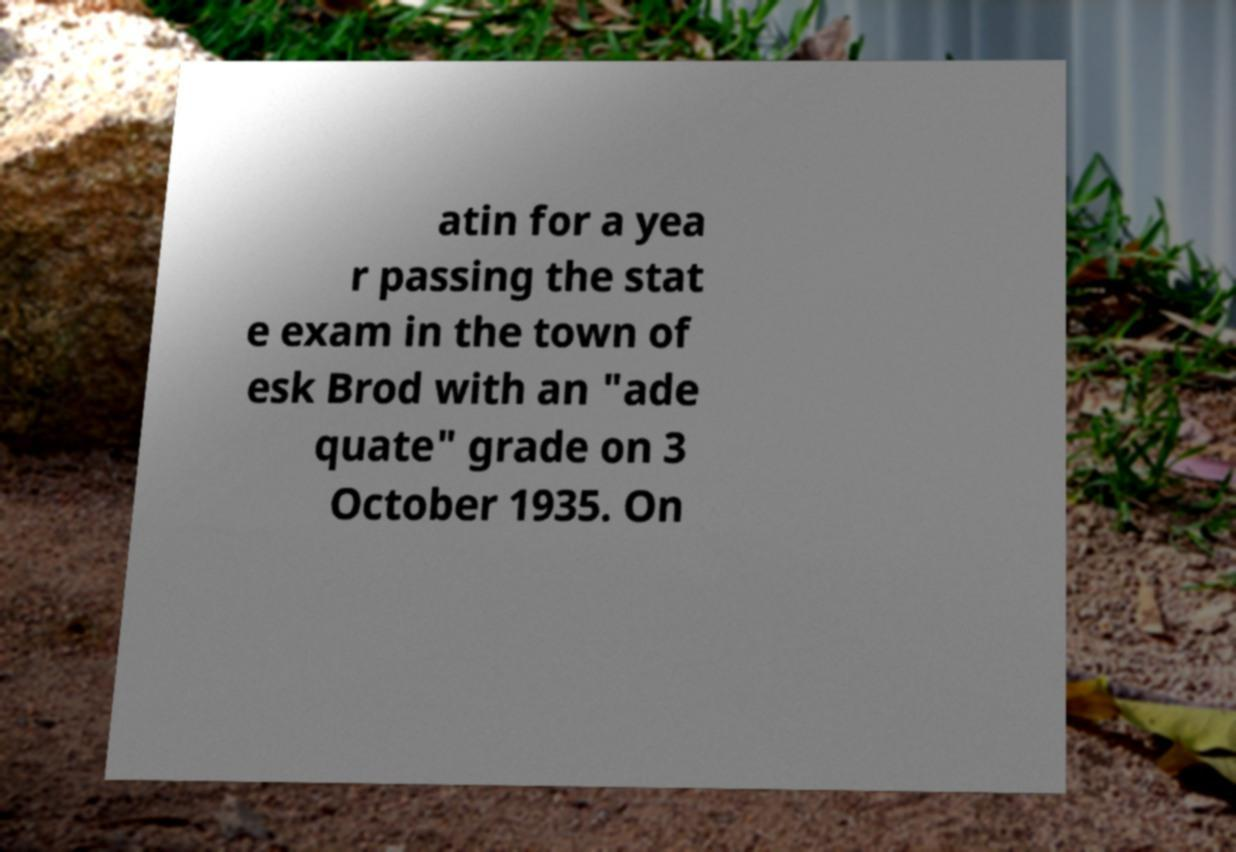There's text embedded in this image that I need extracted. Can you transcribe it verbatim? atin for a yea r passing the stat e exam in the town of esk Brod with an "ade quate" grade on 3 October 1935. On 